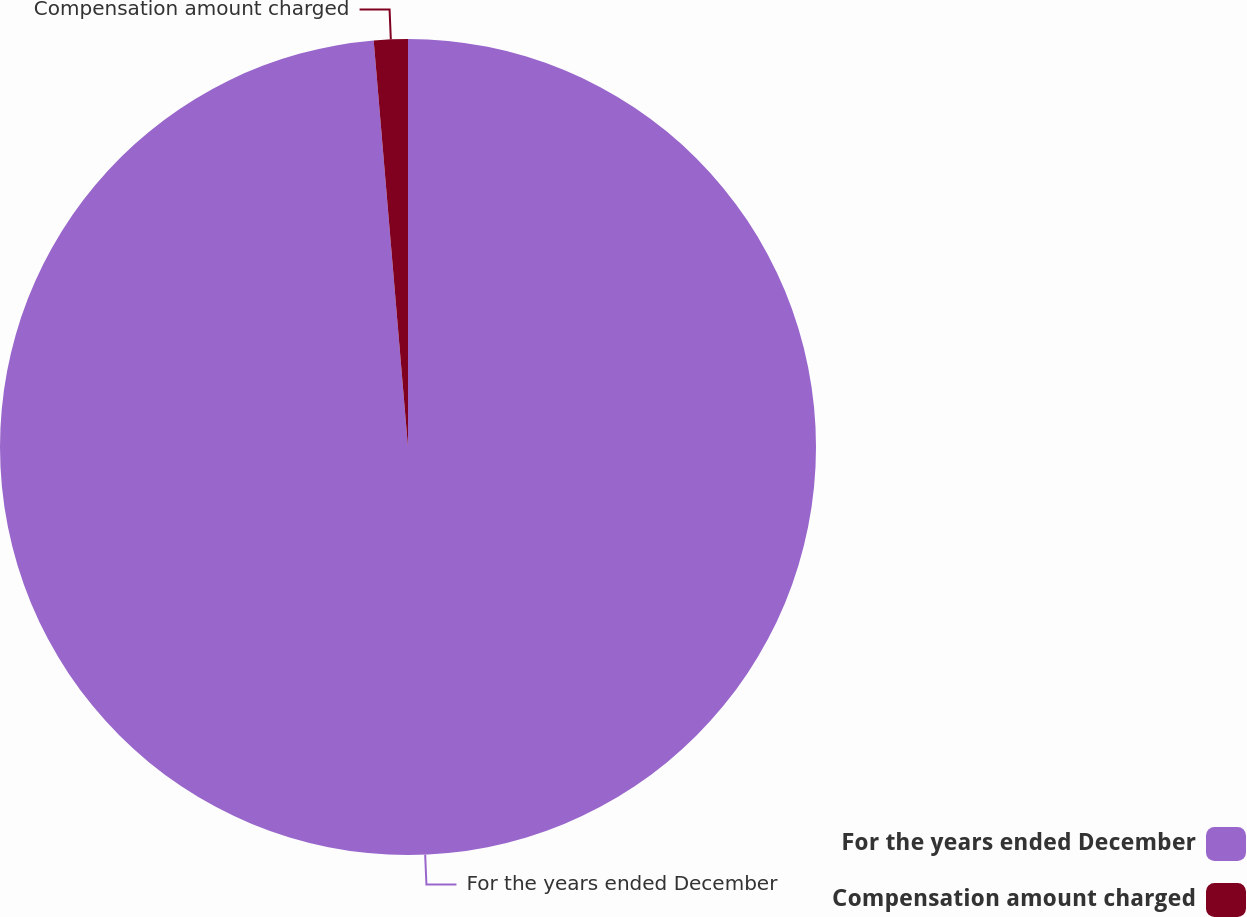Convert chart to OTSL. <chart><loc_0><loc_0><loc_500><loc_500><pie_chart><fcel>For the years ended December<fcel>Compensation amount charged<nl><fcel>98.66%<fcel>1.34%<nl></chart> 